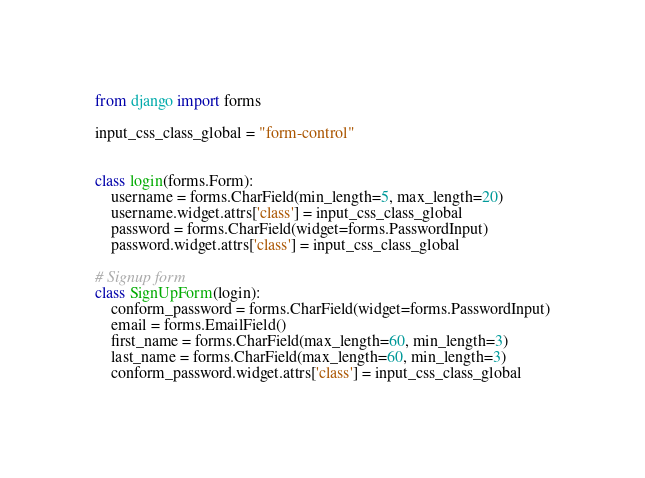<code> <loc_0><loc_0><loc_500><loc_500><_Python_>from django import forms

input_css_class_global = "form-control"


class login(forms.Form):
    username = forms.CharField(min_length=5, max_length=20)
    username.widget.attrs['class'] = input_css_class_global
    password = forms.CharField(widget=forms.PasswordInput)
    password.widget.attrs['class'] = input_css_class_global

# Signup form
class SignUpForm(login):
    conform_password = forms.CharField(widget=forms.PasswordInput)
    email = forms.EmailField()
    first_name = forms.CharField(max_length=60, min_length=3)
    last_name = forms.CharField(max_length=60, min_length=3)
    conform_password.widget.attrs['class'] = input_css_class_global</code> 